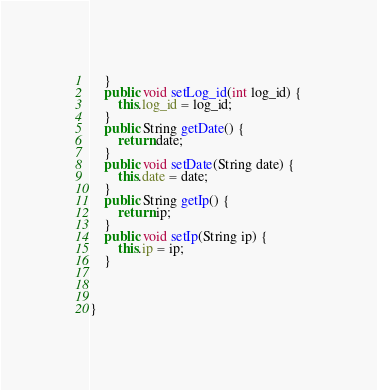Convert code to text. <code><loc_0><loc_0><loc_500><loc_500><_Java_>	}
	public void setLog_id(int log_id) {
		this.log_id = log_id;
	}
	public String getDate() {
		return date;
	}
	public void setDate(String date) {
		this.date = date;
	}
	public String getIp() {
		return ip;
	}
	public void setIp(String ip) {
		this.ip = ip;
	}
	
	

}
</code> 